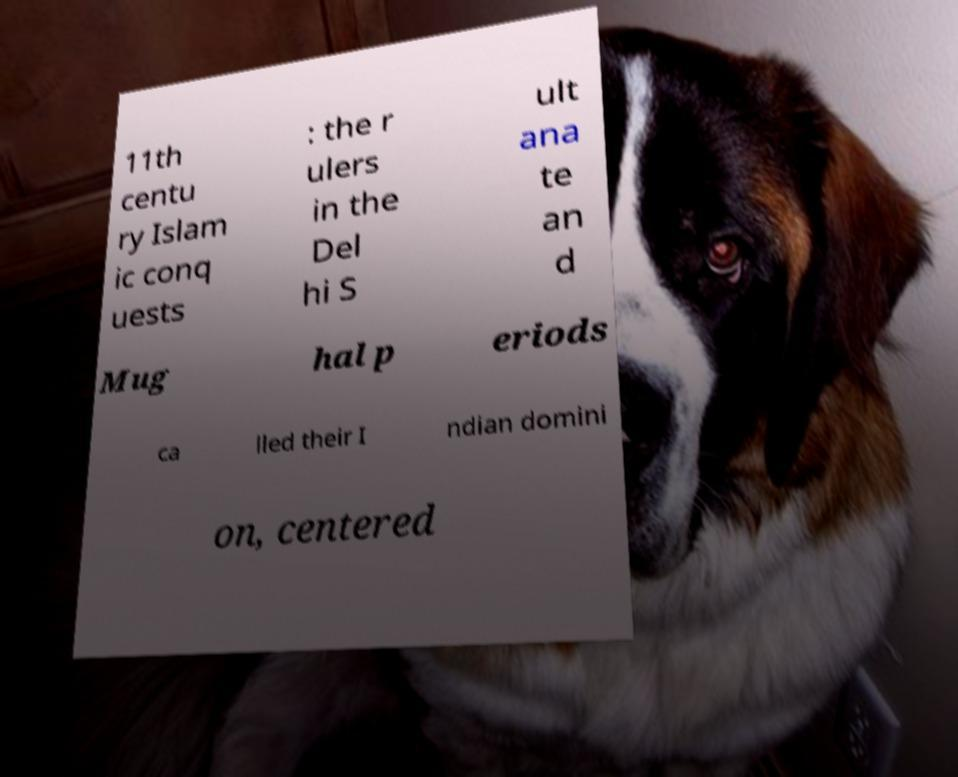Please read and relay the text visible in this image. What does it say? 11th centu ry Islam ic conq uests : the r ulers in the Del hi S ult ana te an d Mug hal p eriods ca lled their I ndian domini on, centered 